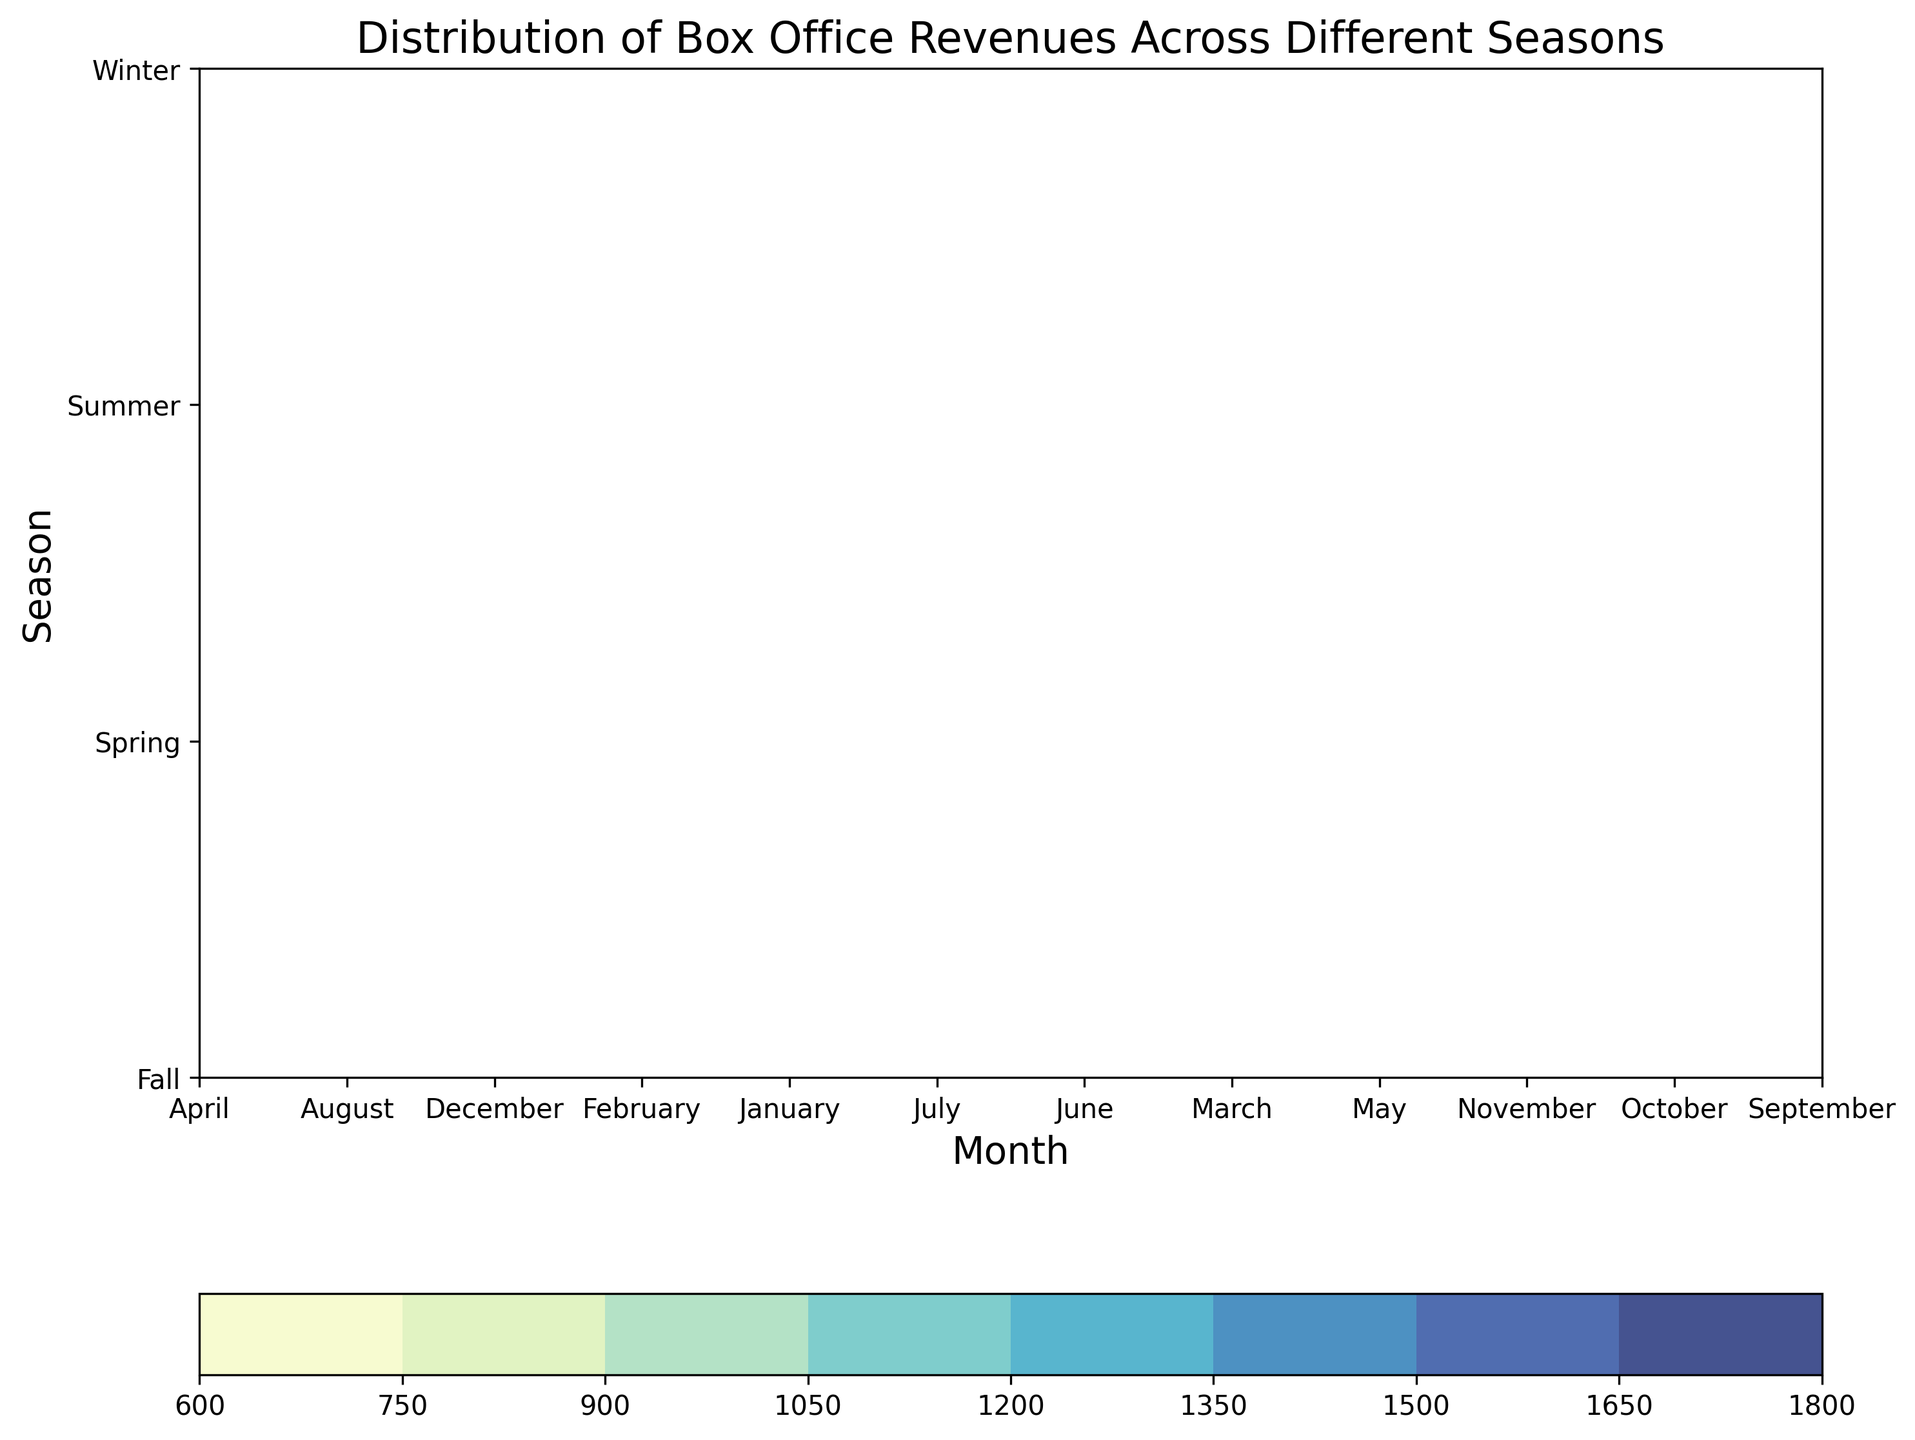What is the average box office revenue in summer? Identify the months in summer (June, July, August) and find the average of revenues: (1465 + 1675 + 1575) / 3 = 4715 / 3 = 1571.67
Answer: 1571.67 In which season do we observe the highest average box office revenue? Compare the average box office revenues across all seasons: Winter (908.33), Spring (1035), Summer (1571.67), Fall (981.67). Summer has the highest average.
Answer: Summer Which month has the highest average box office revenue and in which season is it? Identify months with the highest average box office revenue and locate the season: July (1675), which is in Summer.
Answer: July, Summer Is the average box office revenue higher in March or in September? Compare the average box office revenue in March (885) and September (895): 885 < 895.
Answer: September How does the average box office revenue in winter compare to fall? Compare the average box office revenues in winter (908.33) and fall (981.67): 908.33 < 981.67.
Answer: Lower in winter What range of months has the highest concentration of box office revenues? The highest values on the contour plot are more concentrated in June, July, and August.
Answer: June to August Which season has the lowest variability in box office revenues? Examine the spread on the plot: Fall and Winter have less variability, with more uniform shading.
Answer: Fall What is the color representing the highest box office revenue range? Highest contour levels use a darker shade of blue.
Answer: Dark Blue 